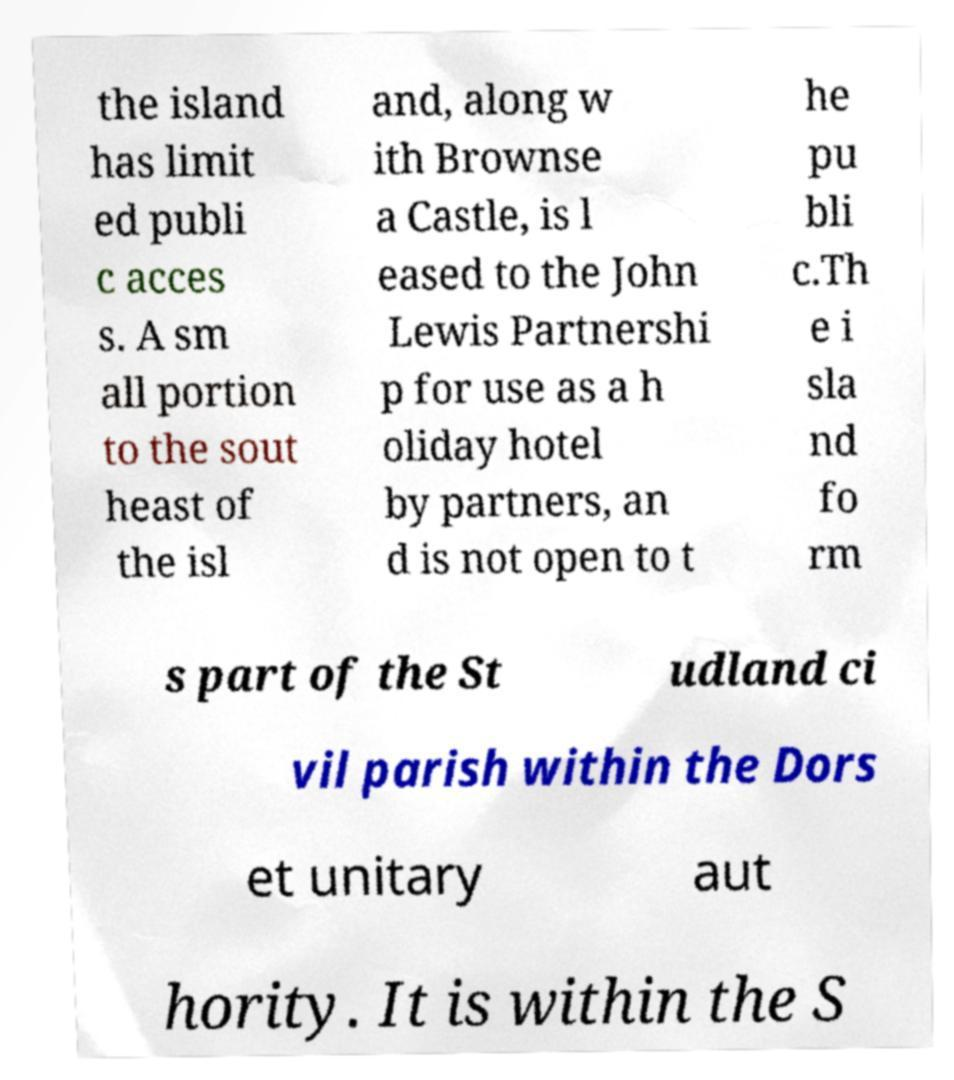Could you assist in decoding the text presented in this image and type it out clearly? the island has limit ed publi c acces s. A sm all portion to the sout heast of the isl and, along w ith Brownse a Castle, is l eased to the John Lewis Partnershi p for use as a h oliday hotel by partners, an d is not open to t he pu bli c.Th e i sla nd fo rm s part of the St udland ci vil parish within the Dors et unitary aut hority. It is within the S 